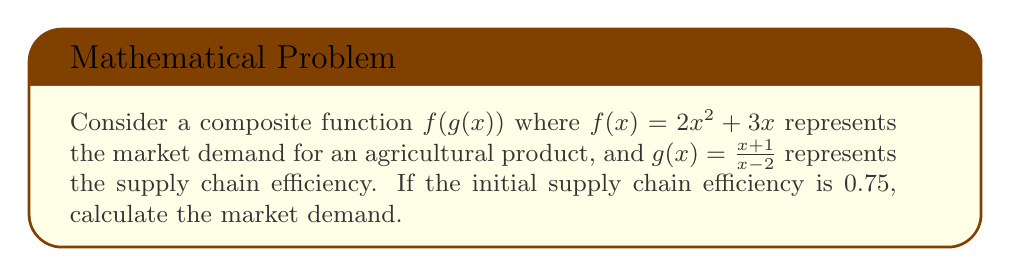Solve this math problem. 1) We are given that $f(x) = 2x^2 + 3x$ and $g(x) = \frac{x+1}{x-2}$.

2) The initial supply chain efficiency is 0.75, so we need to find $g(x) = 0.75$.

3) Solve for x:
   $$\frac{x+1}{x-2} = 0.75$$
   $$x + 1 = 0.75(x - 2)$$
   $$x + 1 = 0.75x - 1.5$$
   $$2.5 = -0.25x$$
   $$x = -10$$

4) Now we need to calculate $f(g(-10))$:
   $$g(-10) = \frac{-10+1}{-10-2} = \frac{-9}{-12} = 0.75$$

5) Finally, calculate $f(0.75)$:
   $$f(0.75) = 2(0.75)^2 + 3(0.75)$$
   $$= 2(0.5625) + 2.25$$
   $$= 1.125 + 2.25$$
   $$= 3.375$$
Answer: 3.375 